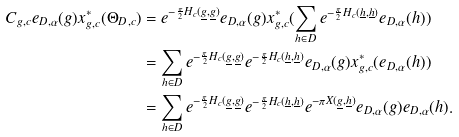<formula> <loc_0><loc_0><loc_500><loc_500>C _ { g , c } e _ { D , \alpha } ( g ) x _ { g , c } ^ { * } ( \Theta _ { D , c } ) & = e ^ { - \frac { \pi } { 2 } H _ { c } ( \underline { g } , \underline { g } ) } e _ { D , \alpha } ( g ) x _ { g , c } ^ { * } ( \sum _ { h \in D } e ^ { - \frac { \pi } { 2 } H _ { c } ( \underline { h } , \underline { h } ) } e _ { D , \alpha } ( h ) ) \\ & = \sum _ { h \in D } e ^ { - \frac { \pi } { 2 } H _ { c } ( \underline { g } , \underline { g } ) } e ^ { - \frac { \pi } { 2 } H _ { c } ( \underline { h } , \underline { h } ) } e _ { D , \alpha } ( g ) x _ { g , c } ^ { * } ( e _ { D , \alpha } ( h ) ) \\ & = \sum _ { h \in D } e ^ { - \frac { \pi } { 2 } H _ { c } ( \underline { g } , \underline { g } ) } e ^ { - \frac { \pi } { 2 } H _ { c } ( \underline { h } , \underline { h } ) } e ^ { - \pi X ( \underline { g } , \underline { h } ) } e _ { D , \alpha } ( g ) e _ { D , \alpha } ( h ) .</formula> 